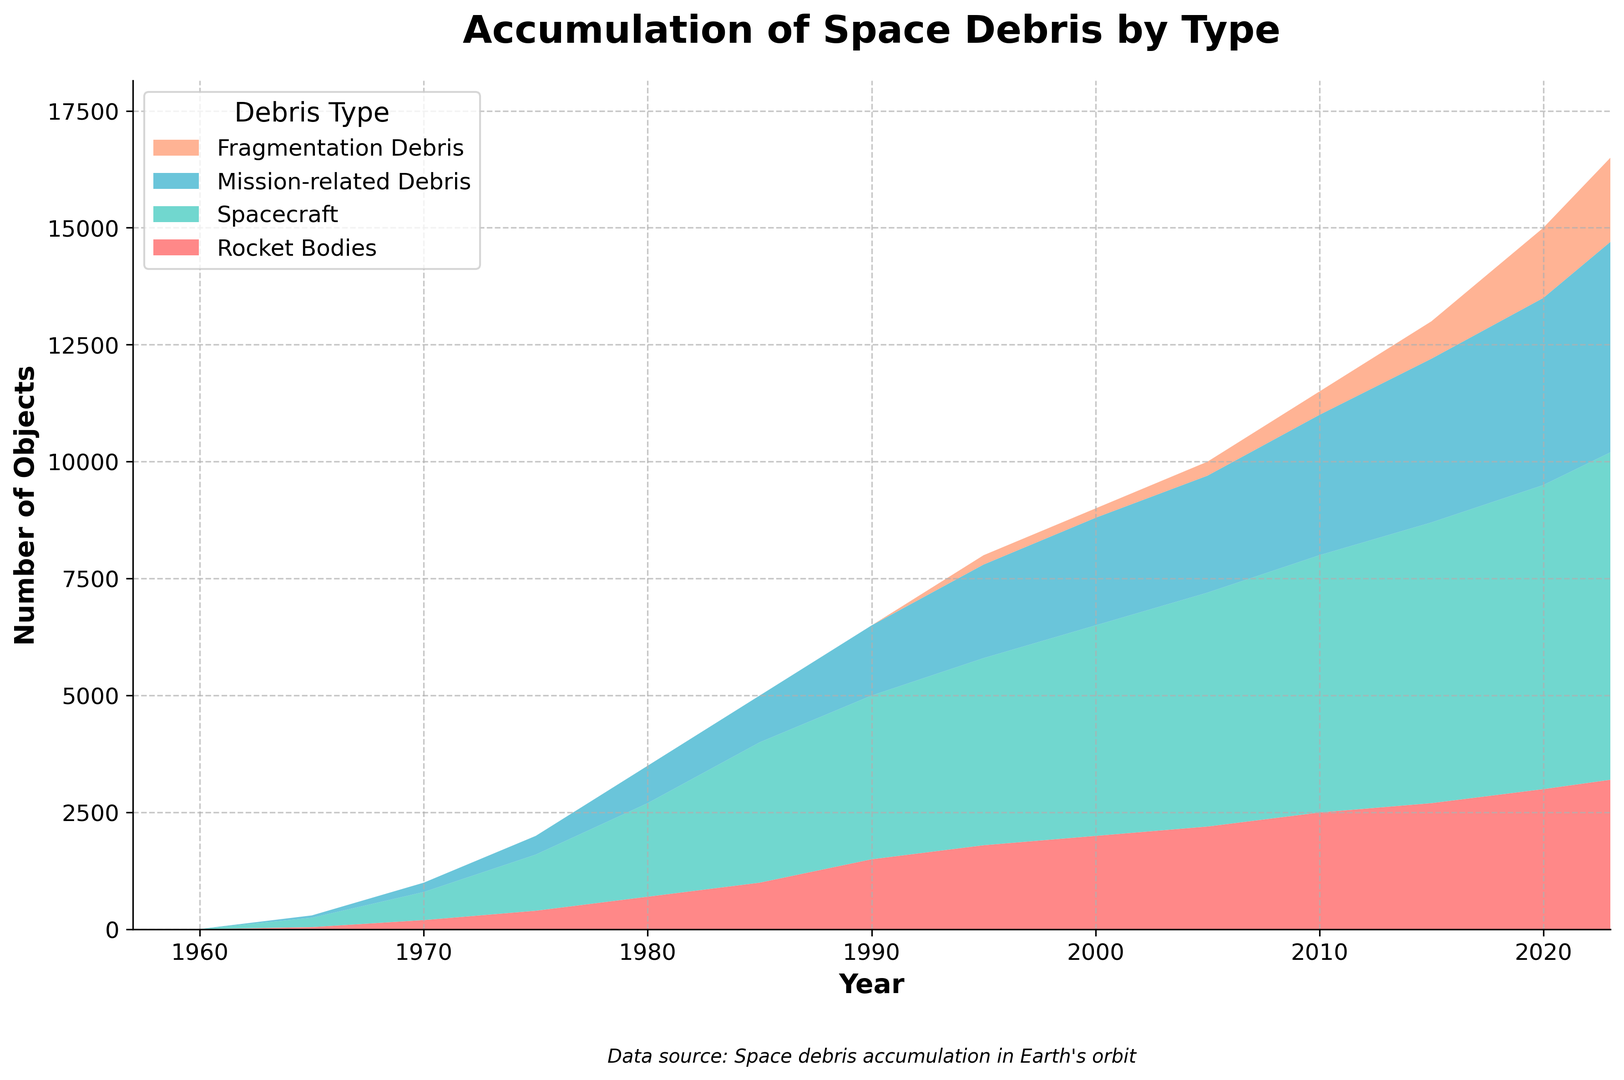What is the overall trend in the accumulation of rocket bodies from 1957 to 2023? The accumulation of rocket bodies demonstrates a steady increase from 1957 to 2023. In 1957, there were 2 rocket bodies, whereas in 2023, the number rises to 3200, indicating continuous growth over the years.
Answer: Increasing Which debris category has shown the most significant increase since 1957? The "Fragmentation Debris" category shows the most significant increase since 1957. Initially, it was 0 in 1957, but by 2023, it increased to 1800, indicating rapid growth.
Answer: Fragmentation Debris Compare the number of spacecraft debris in 1990 and 2023. Which year had more, and by how much? In 1990, there were 3500 spacecraft debris, and in 2023, there are 7000. The difference is 7000 - 3500 = 3500. Thus, 2023 had 3500 more spacecraft debris than 1990.
Answer: 2023, by 3500 What is the total number of mission-related debris in the year 2010? To find the total number, refer to the mission-related debris for the year 2010 which is 3000.
Answer: 3000 Which type of space debris has the highest value by 2023, and what is the total count? The "Small Objects (<1cm)" category has the highest value by 2023, with a total count of 250,000,000.
Answer: Small Objects (<1cm), 250,000,000 How has the number of large objects (>10cm) changed from 1980 to 2020? In 1980, there were 3500 large objects (>10cm), and by 2020, the number increased to 15,000. The change is 15,000 - 3500 = 11,500.
Answer: Increased by 11,500 Compare the total number of space debris categories (Rocket Bodies, Spacecraft, Mission-related Debris, Fragmentation Debris) in 1960 and 2023. Which year had a higher total count and by how much? In 1960, the total count is 5 (Rocket Bodies) + 3 (Spacecraft) + 2 (Mission-related Debris) + 0 (Fragmentation Debris) = 10. In 2023, the total count is 3200 + 7000 + 4500 + 1800 = 16,500. The difference is 16,500 - 10 = 16,490; 2023 had a higher total count by 16,490.
Answer: 2023, by 16,490 